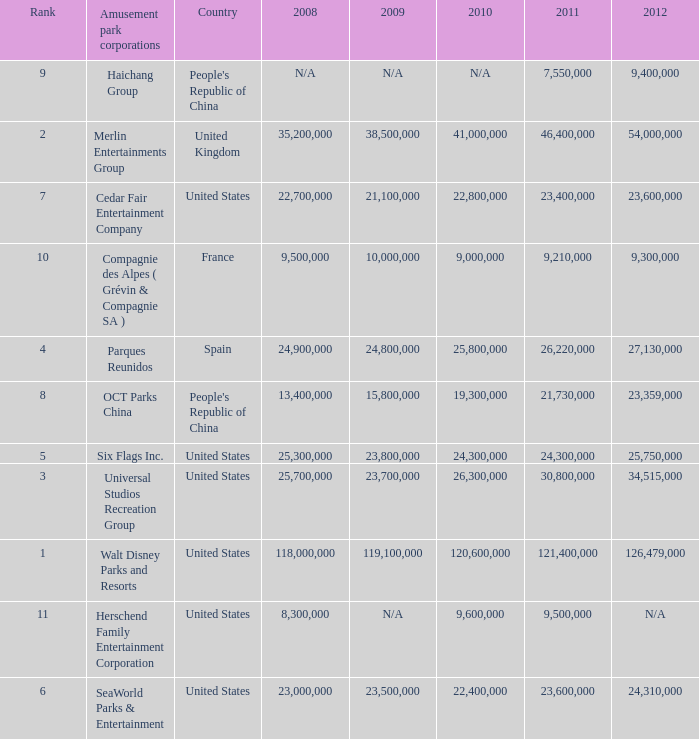In the United States the 2011 attendance at this amusement park corporation was larger than 30,800,000 but lists what as its 2008 attendance? 118000000.0. 